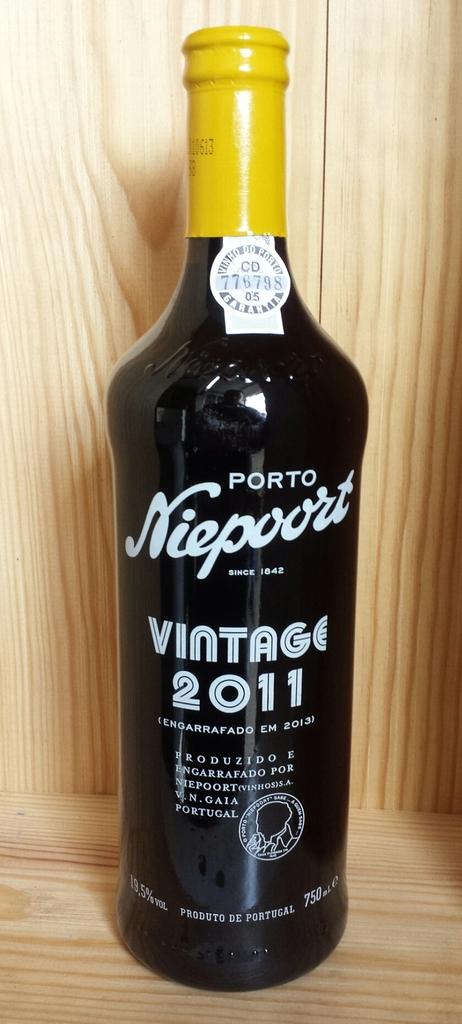What year is written on the bottle?
Keep it short and to the point. 2011. 